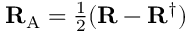<formula> <loc_0><loc_0><loc_500><loc_500>{ R } _ { A } = { \frac { 1 } { 2 } } ( { R } - { R } ^ { \dagger } )</formula> 